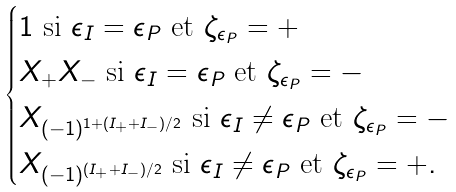Convert formula to latex. <formula><loc_0><loc_0><loc_500><loc_500>\begin{cases} 1 \text { si } \epsilon _ { I } = \epsilon _ { P } \text { et } \zeta _ { \epsilon _ { P } } = + \\ X _ { + } X _ { - } \text { si } \epsilon _ { I } = \epsilon _ { P } \text { et } \zeta _ { \epsilon _ { P } } = - \\ X _ { ( - 1 ) ^ { 1 + ( I _ { + } + I _ { - } ) / 2 } } \text { si } \epsilon _ { I } \neq \epsilon _ { P } \text { et } \zeta _ { \epsilon _ { P } } = - \\ X _ { ( - 1 ) ^ { ( I _ { + } + I _ { - } ) / 2 } } \text { si } \epsilon _ { I } \neq \epsilon _ { P } \text { et } \zeta _ { \epsilon _ { P } } = + . \end{cases}</formula> 